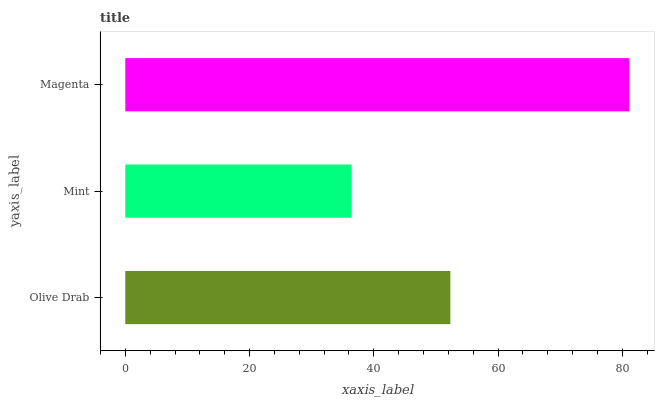Is Mint the minimum?
Answer yes or no. Yes. Is Magenta the maximum?
Answer yes or no. Yes. Is Magenta the minimum?
Answer yes or no. No. Is Mint the maximum?
Answer yes or no. No. Is Magenta greater than Mint?
Answer yes or no. Yes. Is Mint less than Magenta?
Answer yes or no. Yes. Is Mint greater than Magenta?
Answer yes or no. No. Is Magenta less than Mint?
Answer yes or no. No. Is Olive Drab the high median?
Answer yes or no. Yes. Is Olive Drab the low median?
Answer yes or no. Yes. Is Magenta the high median?
Answer yes or no. No. Is Mint the low median?
Answer yes or no. No. 